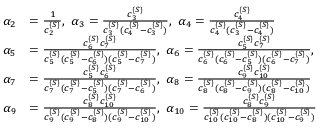<formula> <loc_0><loc_0><loc_500><loc_500>\begin{array} { r l } { \alpha _ { 2 } } & { = \frac { 1 } { c _ { 2 } ^ { \{ S \} } } , \ \alpha _ { 3 } = \frac { c _ { 3 } ^ { \{ S \} } } { c _ { 3 } ^ { \{ S \} } ( c _ { 4 } ^ { \{ S \} } - c _ { 3 } ^ { \{ S \} } ) } , \ \alpha _ { 4 } = \frac { c _ { 4 } ^ { \{ S \} } } { c _ { 4 } ^ { \{ S \} } ( c _ { 3 } ^ { \{ S \} } - c _ { 4 } ^ { \{ S \} } ) } } \\ { \alpha _ { 5 } } & { = \frac { c _ { 6 } ^ { \{ S \} } c _ { 7 } ^ { \{ S \} } } { c _ { 5 } ^ { \{ S \} } ( c _ { 5 } ^ { \{ S \} } - c _ { 6 } ^ { \{ S \} } ) ( c _ { 5 } ^ { \{ S \} } - c _ { 7 } ^ { \{ S \} } ) } , \ \alpha _ { 6 } = \frac { c _ { 5 } ^ { \{ S \} } c _ { 7 } ^ { \{ S \} } } { c _ { 6 } ^ { \{ S \} } ( c _ { 6 } ^ { \{ S \} } - c _ { 5 } ^ { \{ S \} } ) ( c _ { 6 } ^ { \{ S \} } - c _ { 7 } ^ { \{ S \} } ) } , } \\ { \alpha _ { 7 } } & { = \frac { c _ { 5 } ^ { \{ S \} } c _ { 6 } ^ { \{ S \} } } { c _ { 7 } ^ { \{ S \} } ( c _ { 7 } ^ { \{ S \} } - c _ { 5 } ^ { \{ S \} } ) ( c _ { 7 } ^ { \{ S \} } - c _ { 6 } ^ { \{ S \} } ) } , \ \alpha _ { 8 } = \frac { c _ { 9 } ^ { \{ S \} } c _ { 1 0 } ^ { \{ S \} } } { c _ { 8 } ^ { \{ S \} } ( c _ { 8 } ^ { \{ S \} } - c _ { 9 } ^ { \{ S \} } ) ( c _ { 8 } ^ { \{ S \} } - c _ { 1 0 } ^ { \{ S \} } ) } } \\ { \alpha _ { 9 } } & { = \frac { c _ { 8 } ^ { \{ S \} } c _ { 1 0 } ^ { \{ S \} } } { c _ { 9 } ^ { \{ S \} } ( c _ { 9 } ^ { \{ S \} } - c _ { 8 } ^ { \{ S \} } ) ( c _ { 9 } ^ { \{ S \} } - c _ { 1 0 } ^ { \{ S \} } ) } , \ \alpha _ { 1 0 } = \frac { c _ { 8 } ^ { \{ S \} } c _ { 9 } ^ { \{ S \} } } { c _ { 1 0 } ^ { \{ S \} } ( c _ { 1 0 } ^ { \{ S \} } - c _ { 8 } ^ { \{ S \} } ) ( c _ { 1 0 } ^ { \{ S \} } - c _ { 9 } ^ { \{ S \} } ) } } \end{array}</formula> 